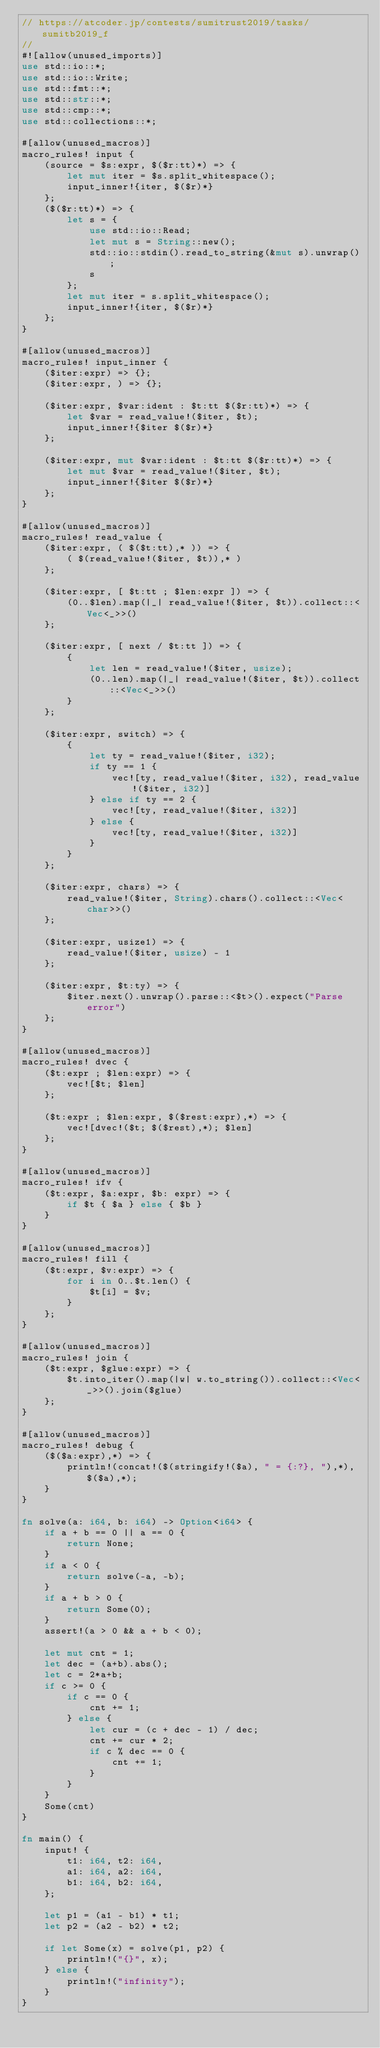Convert code to text. <code><loc_0><loc_0><loc_500><loc_500><_Rust_>// https://atcoder.jp/contests/sumitrust2019/tasks/sumitb2019_f
//
#![allow(unused_imports)]
use std::io::*;
use std::io::Write;
use std::fmt::*;
use std::str::*;
use std::cmp::*;
use std::collections::*;

#[allow(unused_macros)]
macro_rules! input {
    (source = $s:expr, $($r:tt)*) => {
        let mut iter = $s.split_whitespace();
        input_inner!{iter, $($r)*}
    };
    ($($r:tt)*) => {
        let s = {
            use std::io::Read;
            let mut s = String::new();
            std::io::stdin().read_to_string(&mut s).unwrap();
            s
        };
        let mut iter = s.split_whitespace();
        input_inner!{iter, $($r)*}
    };
}

#[allow(unused_macros)]
macro_rules! input_inner {
    ($iter:expr) => {};
    ($iter:expr, ) => {};

    ($iter:expr, $var:ident : $t:tt $($r:tt)*) => {
        let $var = read_value!($iter, $t);
        input_inner!{$iter $($r)*}
    };

    ($iter:expr, mut $var:ident : $t:tt $($r:tt)*) => {
        let mut $var = read_value!($iter, $t);
        input_inner!{$iter $($r)*}
    };
}

#[allow(unused_macros)]
macro_rules! read_value {
    ($iter:expr, ( $($t:tt),* )) => {
        ( $(read_value!($iter, $t)),* )
    };

    ($iter:expr, [ $t:tt ; $len:expr ]) => {
        (0..$len).map(|_| read_value!($iter, $t)).collect::<Vec<_>>()
    };

    ($iter:expr, [ next / $t:tt ]) => {
        {
            let len = read_value!($iter, usize);
            (0..len).map(|_| read_value!($iter, $t)).collect::<Vec<_>>()
        }
    };

    ($iter:expr, switch) => {
        {
            let ty = read_value!($iter, i32);
            if ty == 1 {
                vec![ty, read_value!($iter, i32), read_value!($iter, i32)]
            } else if ty == 2 {
                vec![ty, read_value!($iter, i32)]
            } else {
                vec![ty, read_value!($iter, i32)]
            }
        }
    };

    ($iter:expr, chars) => {
        read_value!($iter, String).chars().collect::<Vec<char>>()
    };

    ($iter:expr, usize1) => {
        read_value!($iter, usize) - 1
    };

    ($iter:expr, $t:ty) => {
        $iter.next().unwrap().parse::<$t>().expect("Parse error")
    };
}

#[allow(unused_macros)]
macro_rules! dvec {
    ($t:expr ; $len:expr) => {
        vec![$t; $len]
    };

    ($t:expr ; $len:expr, $($rest:expr),*) => {
        vec![dvec!($t; $($rest),*); $len]
    };
}

#[allow(unused_macros)]
macro_rules! ifv {
    ($t:expr, $a:expr, $b: expr) => {
        if $t { $a } else { $b }
    }
}

#[allow(unused_macros)]
macro_rules! fill {
    ($t:expr, $v:expr) => {
        for i in 0..$t.len() {
            $t[i] = $v;
        }
    };
}

#[allow(unused_macros)]
macro_rules! join {
    ($t:expr, $glue:expr) => {
        $t.into_iter().map(|w| w.to_string()).collect::<Vec<_>>().join($glue)
    };
}

#[allow(unused_macros)]
macro_rules! debug {
    ($($a:expr),*) => {
        println!(concat!($(stringify!($a), " = {:?}, "),*), $($a),*);
    }
}

fn solve(a: i64, b: i64) -> Option<i64> {
    if a + b == 0 || a == 0 {
        return None;
    }
    if a < 0 {
        return solve(-a, -b);
    }
    if a + b > 0 {
        return Some(0);
    }
    assert!(a > 0 && a + b < 0);

    let mut cnt = 1;
    let dec = (a+b).abs();
    let c = 2*a+b;
    if c >= 0 {
        if c == 0 {
            cnt += 1;
        } else {
            let cur = (c + dec - 1) / dec;
            cnt += cur * 2;
            if c % dec == 0 {
                cnt += 1;
            }
        }
    }
    Some(cnt)
}

fn main() {
    input! {
        t1: i64, t2: i64,
        a1: i64, a2: i64,
        b1: i64, b2: i64,
    };

    let p1 = (a1 - b1) * t1;
    let p2 = (a2 - b2) * t2;

    if let Some(x) = solve(p1, p2) {
        println!("{}", x);
    } else {
        println!("infinity");
    }
}
</code> 